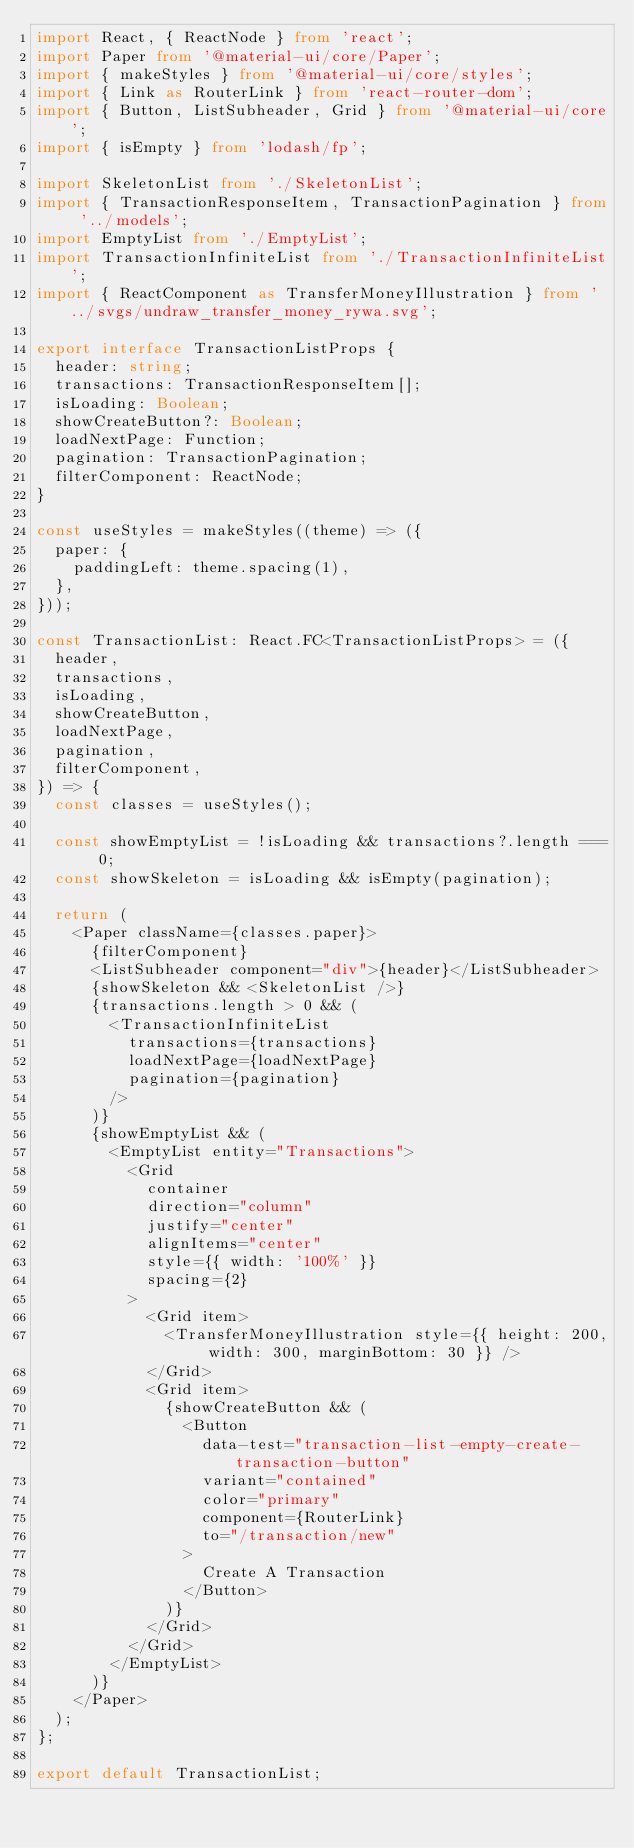Convert code to text. <code><loc_0><loc_0><loc_500><loc_500><_TypeScript_>import React, { ReactNode } from 'react';
import Paper from '@material-ui/core/Paper';
import { makeStyles } from '@material-ui/core/styles';
import { Link as RouterLink } from 'react-router-dom';
import { Button, ListSubheader, Grid } from '@material-ui/core';
import { isEmpty } from 'lodash/fp';

import SkeletonList from './SkeletonList';
import { TransactionResponseItem, TransactionPagination } from '../models';
import EmptyList from './EmptyList';
import TransactionInfiniteList from './TransactionInfiniteList';
import { ReactComponent as TransferMoneyIllustration } from '../svgs/undraw_transfer_money_rywa.svg';

export interface TransactionListProps {
  header: string;
  transactions: TransactionResponseItem[];
  isLoading: Boolean;
  showCreateButton?: Boolean;
  loadNextPage: Function;
  pagination: TransactionPagination;
  filterComponent: ReactNode;
}

const useStyles = makeStyles((theme) => ({
  paper: {
    paddingLeft: theme.spacing(1),
  },
}));

const TransactionList: React.FC<TransactionListProps> = ({
  header,
  transactions,
  isLoading,
  showCreateButton,
  loadNextPage,
  pagination,
  filterComponent,
}) => {
  const classes = useStyles();

  const showEmptyList = !isLoading && transactions?.length === 0;
  const showSkeleton = isLoading && isEmpty(pagination);

  return (
    <Paper className={classes.paper}>
      {filterComponent}
      <ListSubheader component="div">{header}</ListSubheader>
      {showSkeleton && <SkeletonList />}
      {transactions.length > 0 && (
        <TransactionInfiniteList
          transactions={transactions}
          loadNextPage={loadNextPage}
          pagination={pagination}
        />
      )}
      {showEmptyList && (
        <EmptyList entity="Transactions">
          <Grid
            container
            direction="column"
            justify="center"
            alignItems="center"
            style={{ width: '100%' }}
            spacing={2}
          >
            <Grid item>
              <TransferMoneyIllustration style={{ height: 200, width: 300, marginBottom: 30 }} />
            </Grid>
            <Grid item>
              {showCreateButton && (
                <Button
                  data-test="transaction-list-empty-create-transaction-button"
                  variant="contained"
                  color="primary"
                  component={RouterLink}
                  to="/transaction/new"
                >
                  Create A Transaction
                </Button>
              )}
            </Grid>
          </Grid>
        </EmptyList>
      )}
    </Paper>
  );
};

export default TransactionList;
</code> 